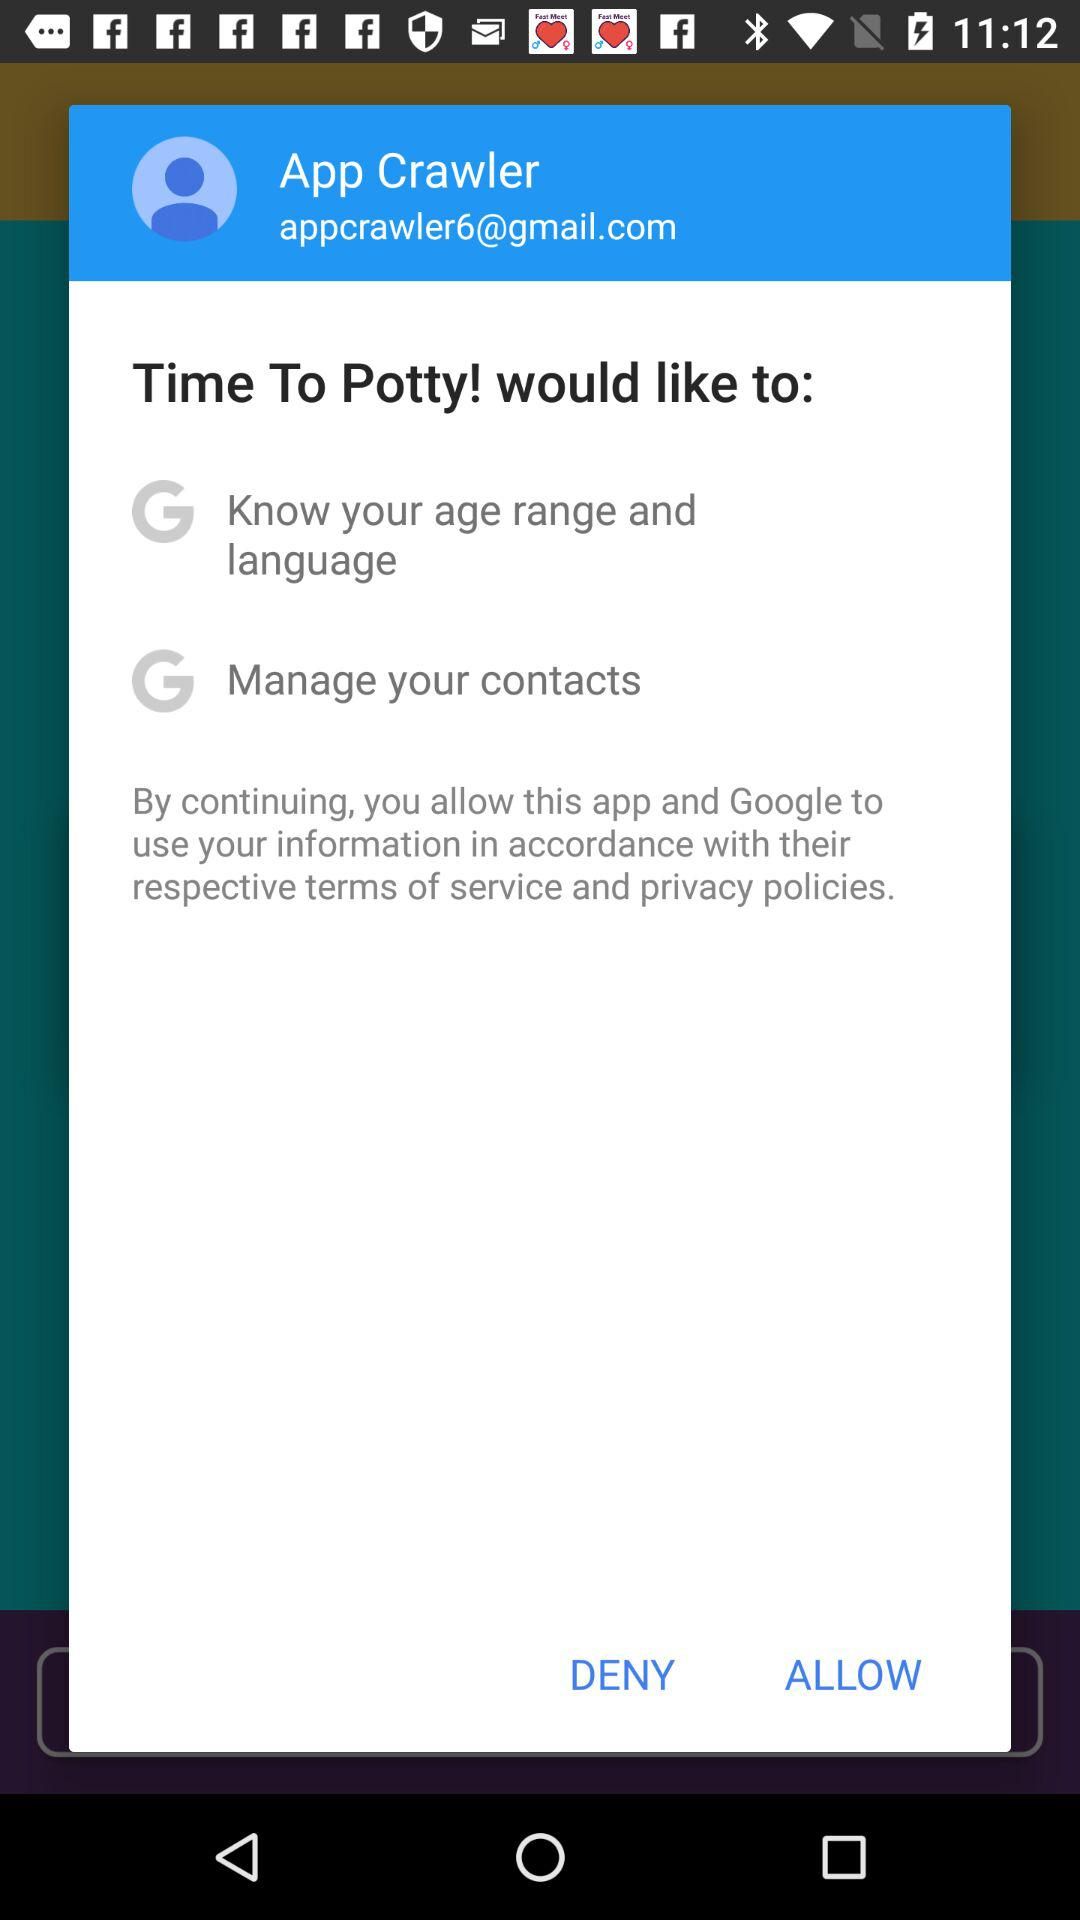What is the user name? The user name is App Crawler. 